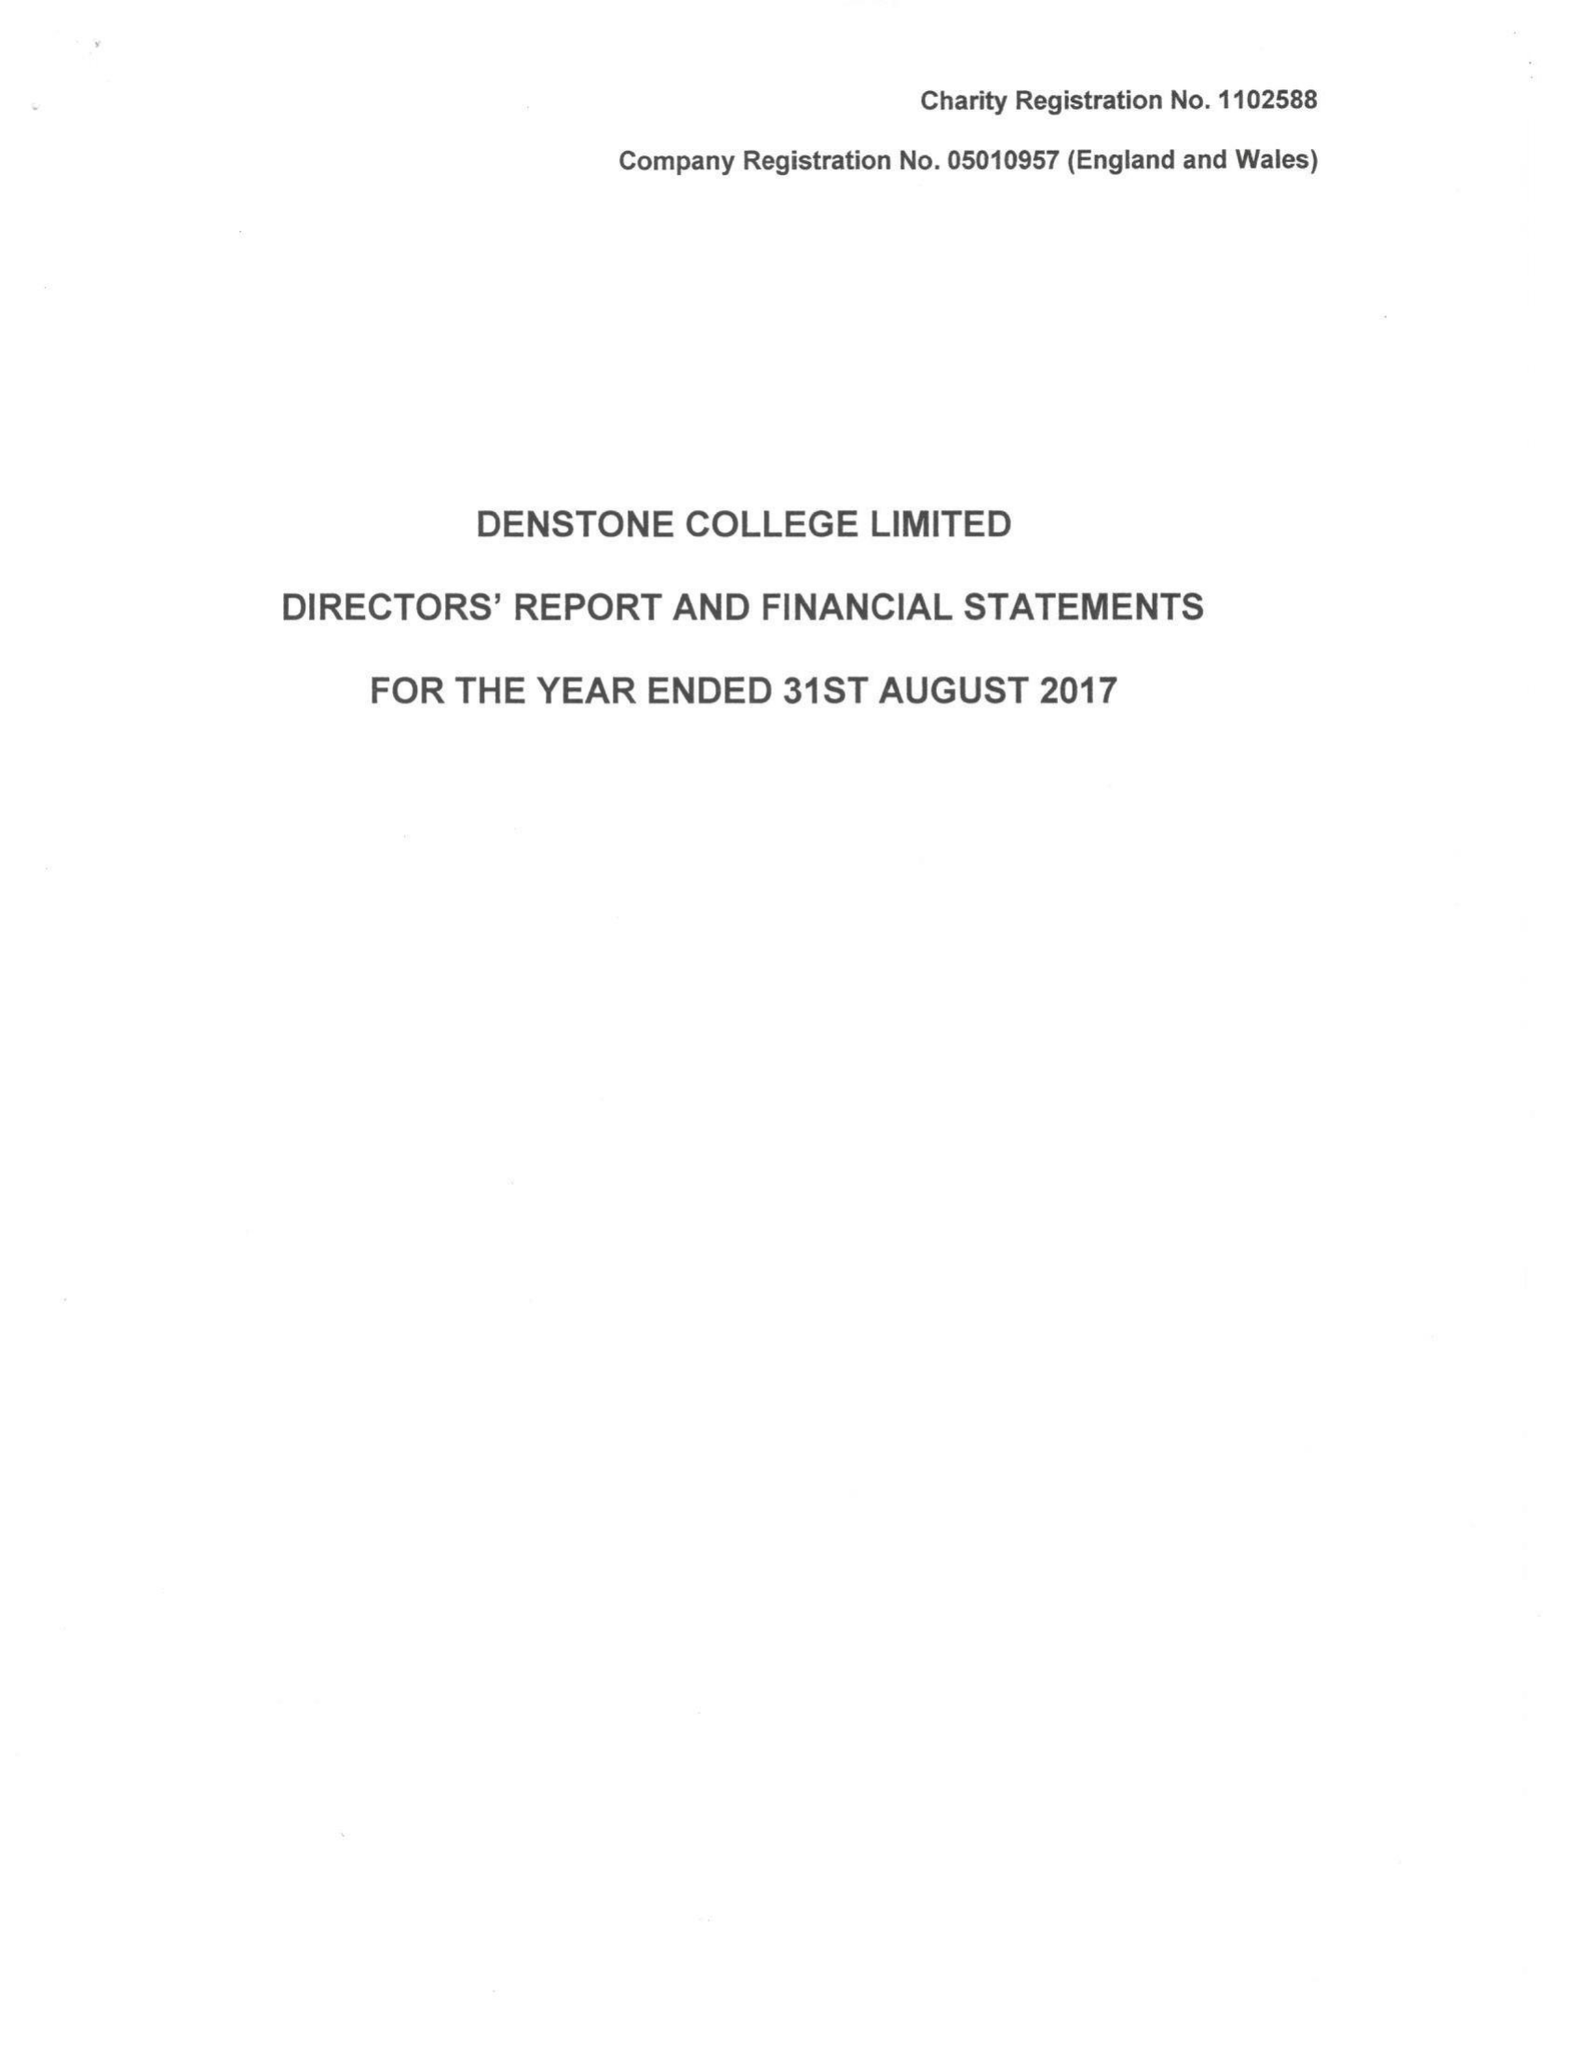What is the value for the charity_name?
Answer the question using a single word or phrase. Denstone College Ltd. 